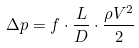<formula> <loc_0><loc_0><loc_500><loc_500>\Delta p = f \cdot \frac { L } { D } \cdot \frac { \rho V ^ { 2 } } { 2 }</formula> 